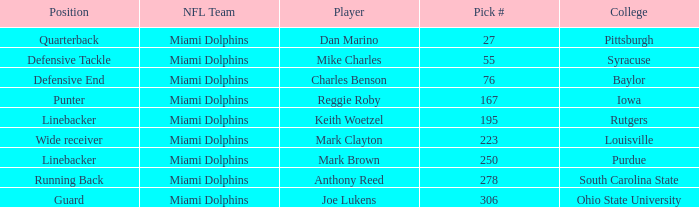If the Position is Running Back what is the Total number of Pick #? 1.0. 